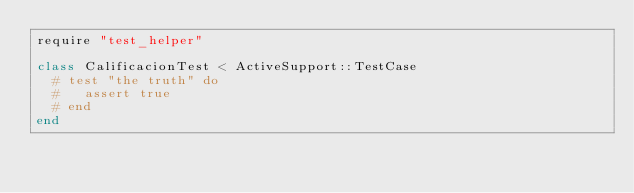Convert code to text. <code><loc_0><loc_0><loc_500><loc_500><_Ruby_>require "test_helper"

class CalificacionTest < ActiveSupport::TestCase
  # test "the truth" do
  #   assert true
  # end
end
</code> 